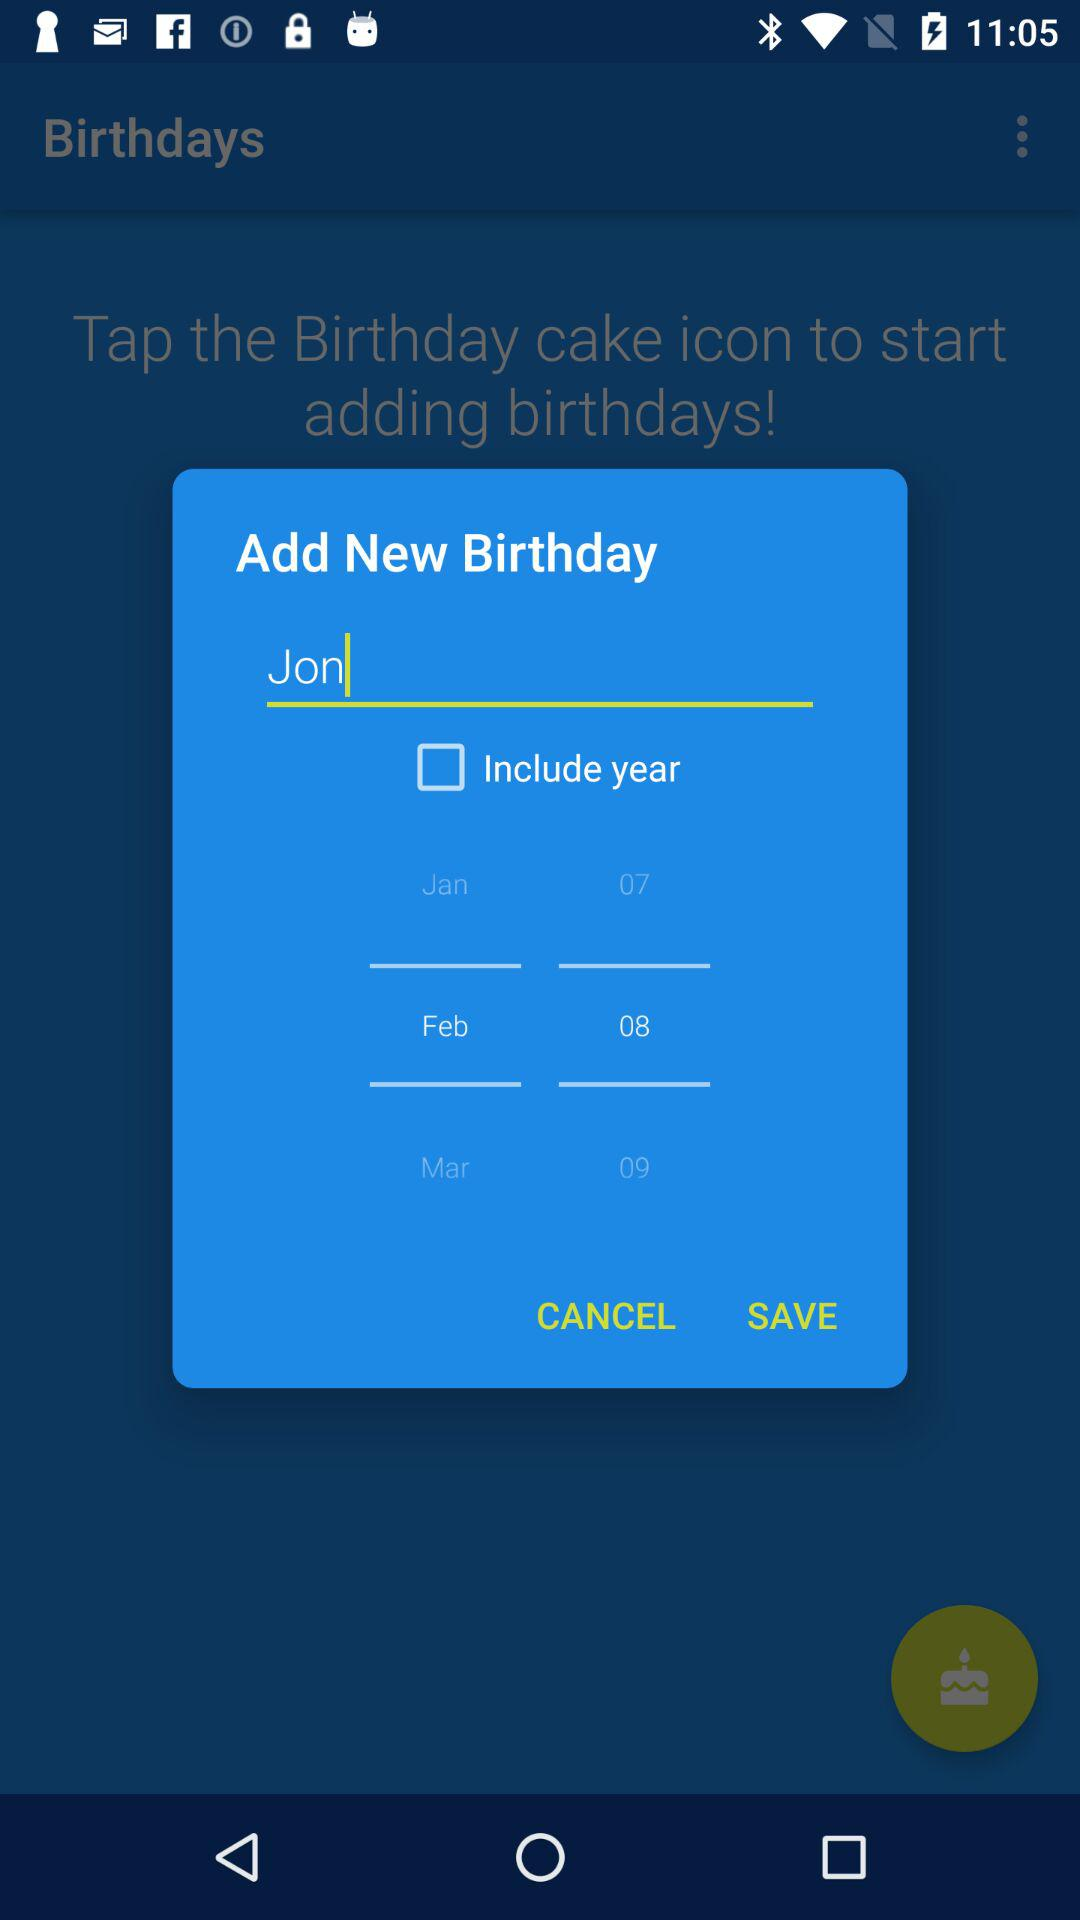What is the selected month and date? The selected date is February 8. 